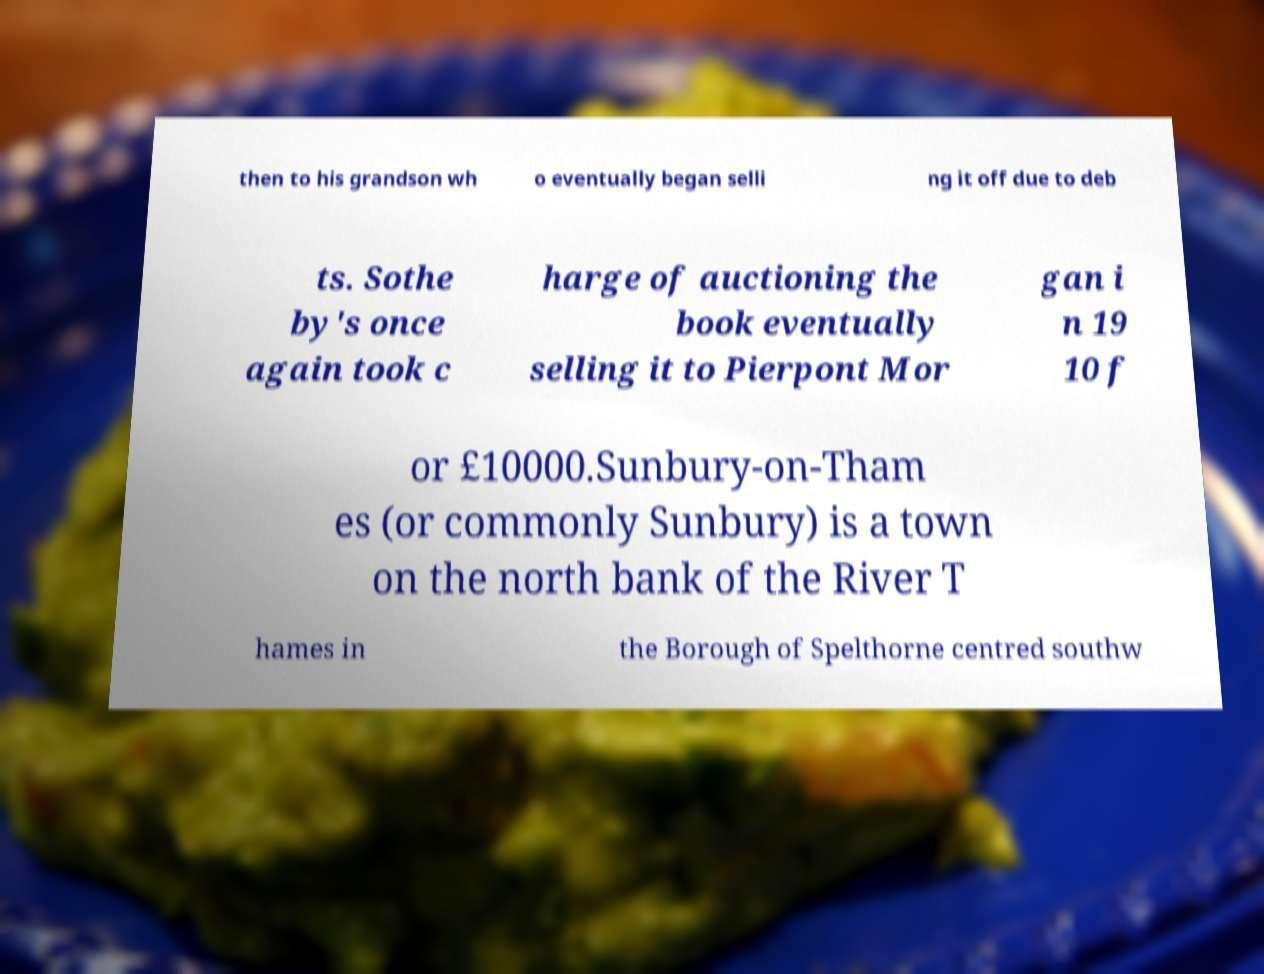Can you read and provide the text displayed in the image?This photo seems to have some interesting text. Can you extract and type it out for me? then to his grandson wh o eventually began selli ng it off due to deb ts. Sothe by's once again took c harge of auctioning the book eventually selling it to Pierpont Mor gan i n 19 10 f or £10000.Sunbury-on-Tham es (or commonly Sunbury) is a town on the north bank of the River T hames in the Borough of Spelthorne centred southw 